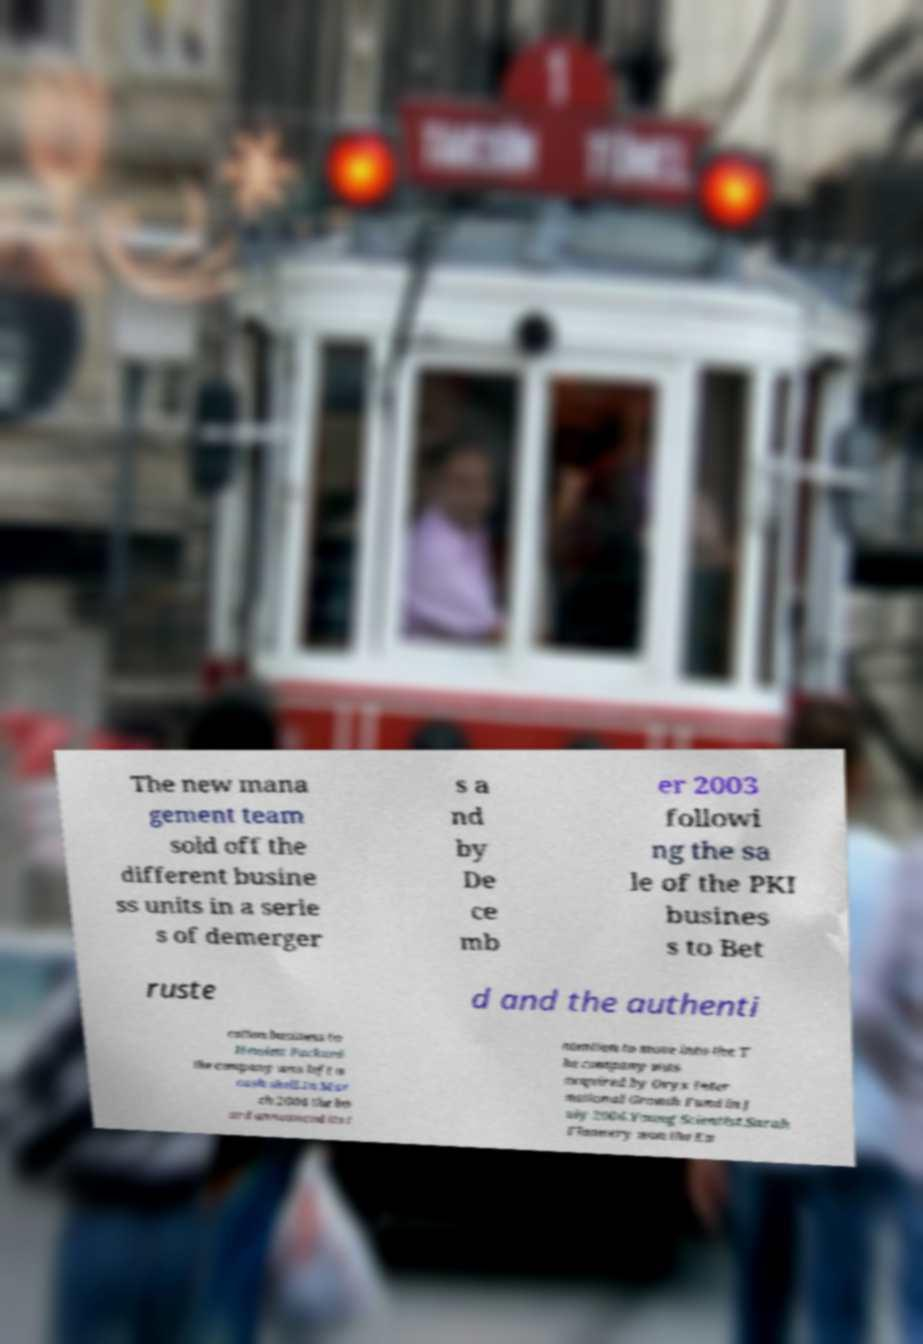Please read and relay the text visible in this image. What does it say? The new mana gement team sold off the different busine ss units in a serie s of demerger s a nd by De ce mb er 2003 followi ng the sa le of the PKI busines s to Bet ruste d and the authenti cation business to Hewlett Packard the company was left a cash shell.In Mar ch 2004 the bo ard announced its i ntention to move into the T he company was acquired by Oryx Inter national Growth Fund in J uly 2006.Young Scientist.Sarah Flannery won the Eu 